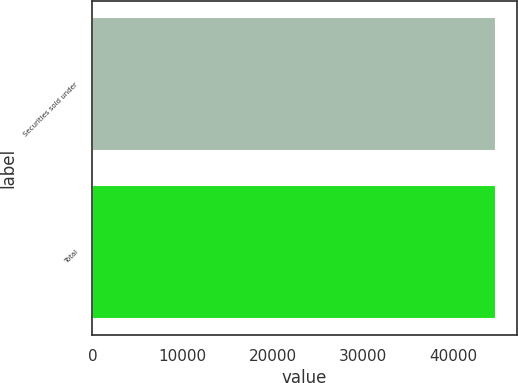Convert chart to OTSL. <chart><loc_0><loc_0><loc_500><loc_500><bar_chart><fcel>Securities sold under<fcel>Total<nl><fcel>44811<fcel>44811.1<nl></chart> 